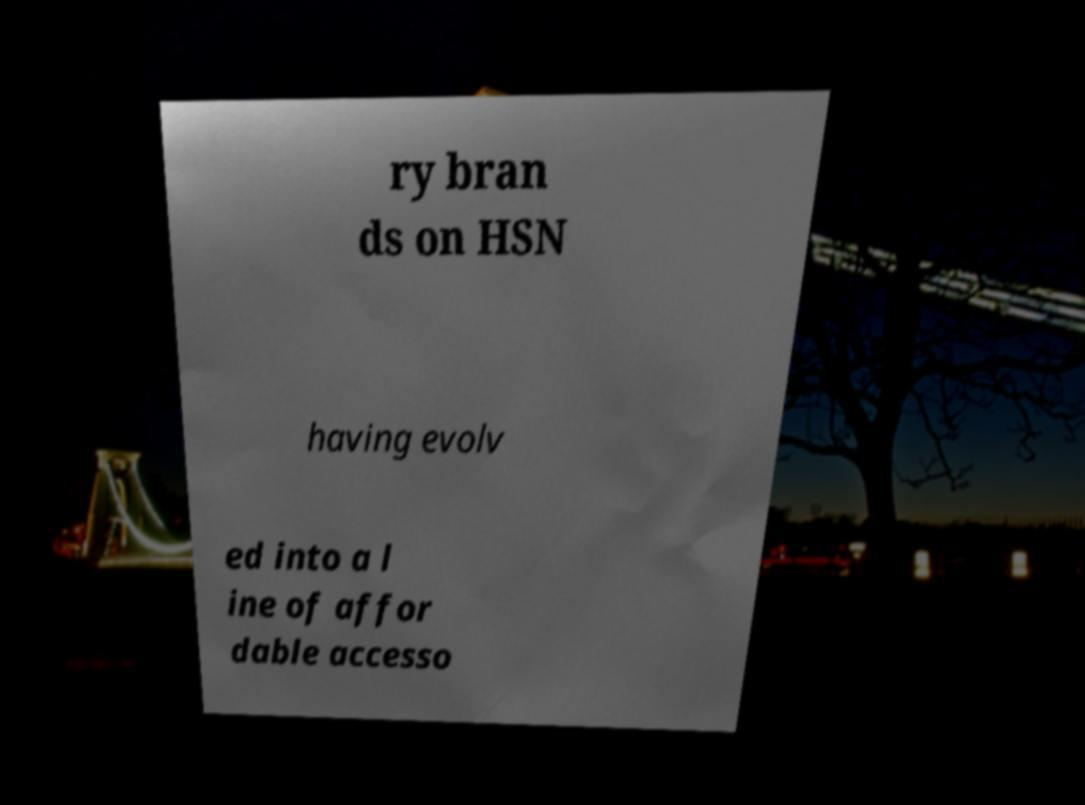Please identify and transcribe the text found in this image. ry bran ds on HSN having evolv ed into a l ine of affor dable accesso 